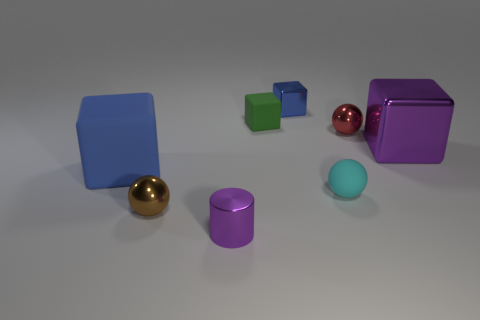There is a big thing that is behind the blue block that is in front of the red object; what number of big rubber cubes are in front of it?
Your response must be concise. 1. What material is the brown thing that is the same shape as the red object?
Your answer should be very brief. Metal. What is the block that is both left of the big shiny cube and in front of the green matte thing made of?
Offer a terse response. Rubber. Is the number of rubber cubes that are behind the blue rubber thing less than the number of blocks that are on the right side of the cylinder?
Make the answer very short. Yes. What number of other objects are there of the same size as the blue matte thing?
Keep it short and to the point. 1. There is a blue thing to the left of the blue metallic cube that is to the right of the brown ball left of the small blue thing; what is its shape?
Your answer should be compact. Cube. What number of cyan objects are either rubber blocks or large matte things?
Ensure brevity in your answer.  0. What number of tiny blue shiny blocks are behind the blue cube behind the small green rubber thing?
Provide a short and direct response. 0. Are there any other things of the same color as the small matte sphere?
Ensure brevity in your answer.  No. There is a tiny brown thing that is the same material as the red thing; what is its shape?
Ensure brevity in your answer.  Sphere. 